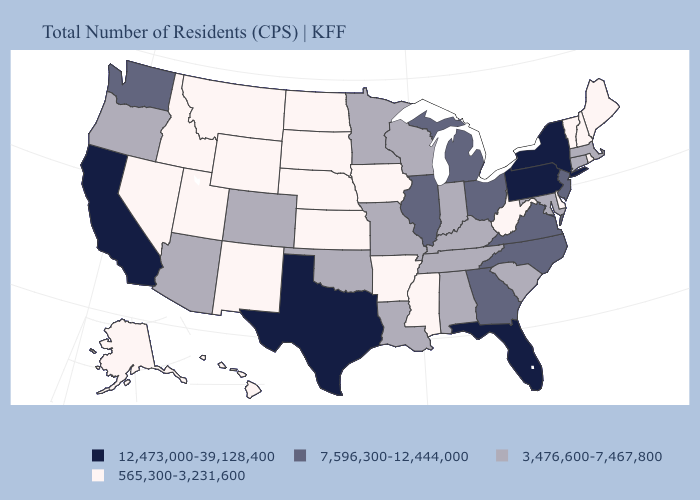Does South Carolina have a lower value than Louisiana?
Be succinct. No. Does Missouri have the lowest value in the USA?
Keep it brief. No. Does Alaska have a higher value than Utah?
Quick response, please. No. Which states hav the highest value in the Northeast?
Quick response, please. New York, Pennsylvania. Among the states that border Washington , which have the lowest value?
Write a very short answer. Idaho. What is the highest value in the South ?
Quick response, please. 12,473,000-39,128,400. What is the value of Indiana?
Be succinct. 3,476,600-7,467,800. Is the legend a continuous bar?
Quick response, please. No. Which states have the lowest value in the Northeast?
Concise answer only. Maine, New Hampshire, Rhode Island, Vermont. What is the value of Arkansas?
Concise answer only. 565,300-3,231,600. What is the lowest value in the Northeast?
Write a very short answer. 565,300-3,231,600. Which states have the highest value in the USA?
Answer briefly. California, Florida, New York, Pennsylvania, Texas. What is the value of Illinois?
Quick response, please. 7,596,300-12,444,000. Name the states that have a value in the range 12,473,000-39,128,400?
Write a very short answer. California, Florida, New York, Pennsylvania, Texas. Does Arkansas have a lower value than Minnesota?
Give a very brief answer. Yes. 